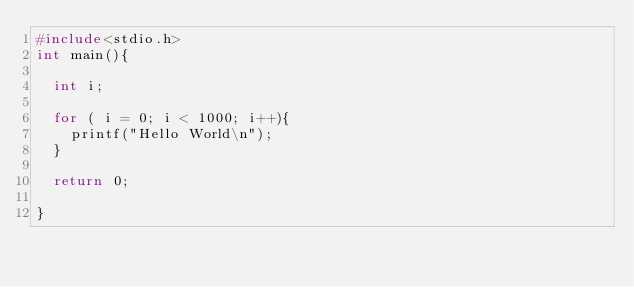Convert code to text. <code><loc_0><loc_0><loc_500><loc_500><_C_>#include<stdio.h>
int main(){

  int i;

  for ( i = 0; i < 1000; i++){
    printf("Hello World\n");
  }
  
  return 0;

}</code> 